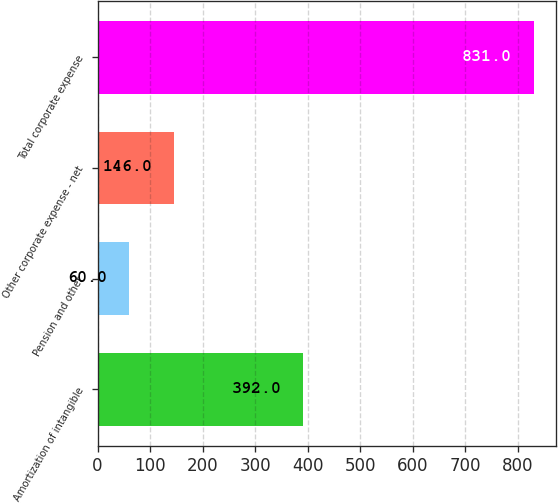Convert chart to OTSL. <chart><loc_0><loc_0><loc_500><loc_500><bar_chart><fcel>Amortization of intangible<fcel>Pension and other<fcel>Other corporate expense - net<fcel>Total corporate expense<nl><fcel>392<fcel>60<fcel>146<fcel>831<nl></chart> 